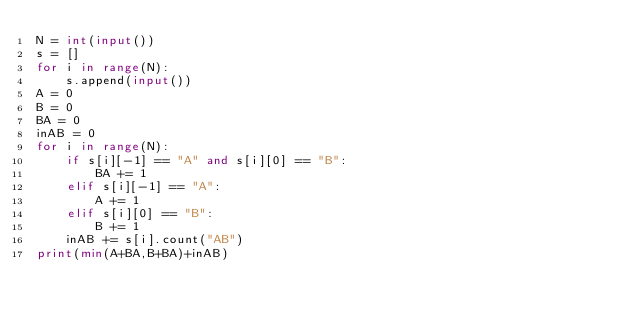<code> <loc_0><loc_0><loc_500><loc_500><_Python_>N = int(input())
s = []
for i in range(N):
    s.append(input())
A = 0
B = 0
BA = 0
inAB = 0
for i in range(N):
    if s[i][-1] == "A" and s[i][0] == "B":
        BA += 1
    elif s[i][-1] == "A":
        A += 1
    elif s[i][0] == "B":
        B += 1
    inAB += s[i].count("AB")
print(min(A+BA,B+BA)+inAB)</code> 